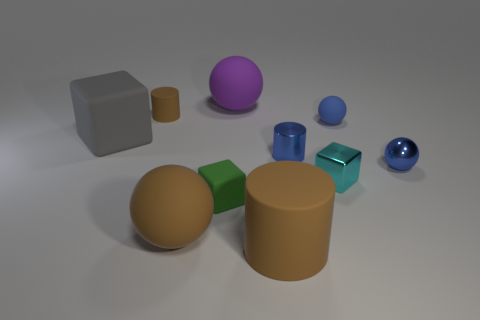There is a rubber ball that is the same color as the metallic ball; what is its size?
Keep it short and to the point. Small. Is the color of the tiny shiny sphere the same as the tiny metallic cylinder?
Your answer should be very brief. Yes. There is a tiny thing that is the same color as the big matte cylinder; what shape is it?
Your answer should be compact. Cylinder. What shape is the big object that is both behind the cyan block and in front of the big purple thing?
Ensure brevity in your answer.  Cube. Is the color of the rubber sphere that is on the right side of the purple thing the same as the small metallic ball?
Make the answer very short. Yes. How big is the thing that is in front of the gray matte object and behind the tiny metal sphere?
Your answer should be compact. Small. There is a small cylinder that is the same color as the tiny matte ball; what is its material?
Provide a succinct answer. Metal. Is there a tiny thing made of the same material as the cyan block?
Ensure brevity in your answer.  Yes. Are there any cylinders that are in front of the matte object right of the large thing right of the purple object?
Offer a very short reply. Yes. What number of other objects are there of the same shape as the big purple thing?
Your answer should be compact. 3. 